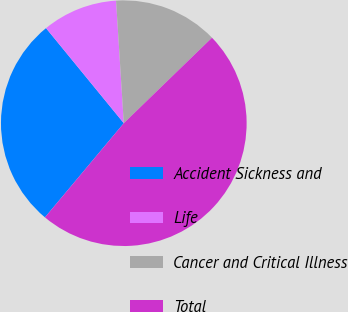Convert chart to OTSL. <chart><loc_0><loc_0><loc_500><loc_500><pie_chart><fcel>Accident Sickness and<fcel>Life<fcel>Cancer and Critical Illness<fcel>Total<nl><fcel>27.99%<fcel>9.91%<fcel>13.75%<fcel>48.34%<nl></chart> 